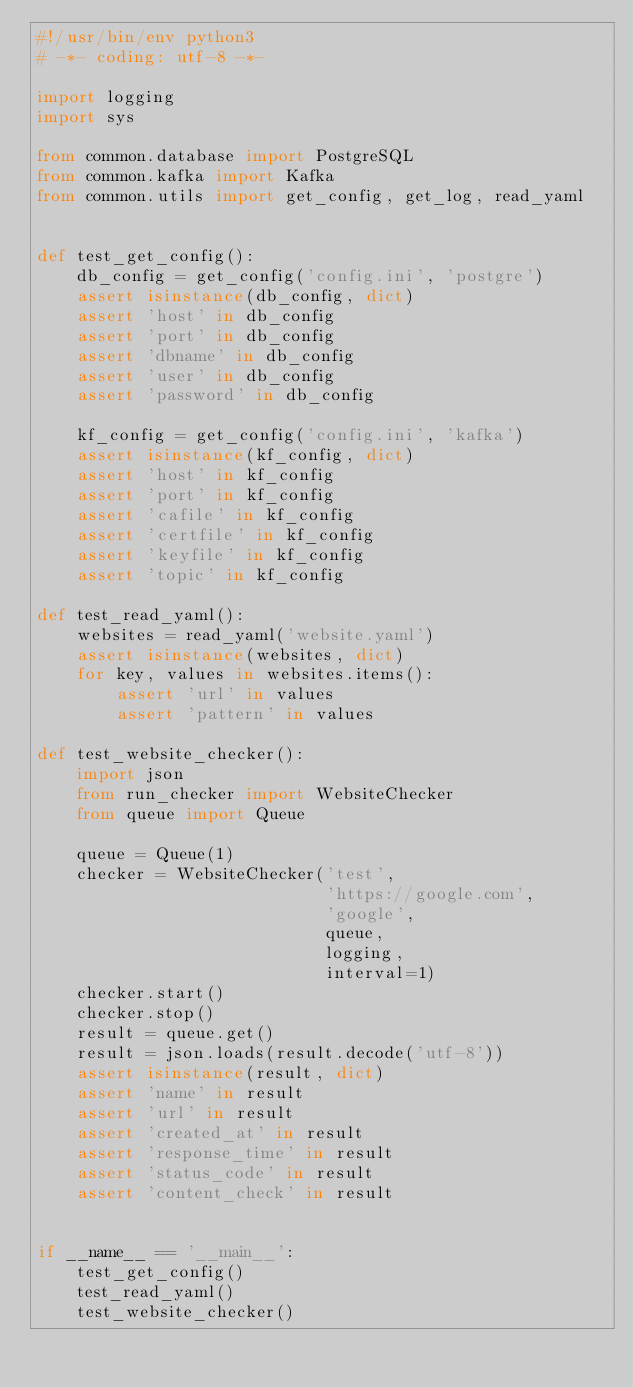Convert code to text. <code><loc_0><loc_0><loc_500><loc_500><_Python_>#!/usr/bin/env python3
# -*- coding: utf-8 -*-

import logging
import sys

from common.database import PostgreSQL
from common.kafka import Kafka
from common.utils import get_config, get_log, read_yaml


def test_get_config():
    db_config = get_config('config.ini', 'postgre')
    assert isinstance(db_config, dict)
    assert 'host' in db_config
    assert 'port' in db_config
    assert 'dbname' in db_config
    assert 'user' in db_config
    assert 'password' in db_config

    kf_config = get_config('config.ini', 'kafka')
    assert isinstance(kf_config, dict)
    assert 'host' in kf_config
    assert 'port' in kf_config
    assert 'cafile' in kf_config
    assert 'certfile' in kf_config
    assert 'keyfile' in kf_config
    assert 'topic' in kf_config

def test_read_yaml():
    websites = read_yaml('website.yaml')
    assert isinstance(websites, dict)
    for key, values in websites.items():
        assert 'url' in values
        assert 'pattern' in values

def test_website_checker():
    import json
    from run_checker import WebsiteChecker
    from queue import Queue

    queue = Queue(1)
    checker = WebsiteChecker('test',
                             'https://google.com',
                             'google',
                             queue,
                             logging,
                             interval=1)
    checker.start()
    checker.stop()
    result = queue.get()
    result = json.loads(result.decode('utf-8'))
    assert isinstance(result, dict)
    assert 'name' in result
    assert 'url' in result
    assert 'created_at' in result
    assert 'response_time' in result
    assert 'status_code' in result
    assert 'content_check' in result


if __name__ == '__main__':
    test_get_config()
    test_read_yaml()
    test_website_checker()
</code> 